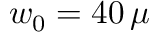Convert formula to latex. <formula><loc_0><loc_0><loc_500><loc_500>w _ { 0 } = 4 0 \, \mu</formula> 